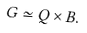Convert formula to latex. <formula><loc_0><loc_0><loc_500><loc_500>G \simeq Q \times B .</formula> 